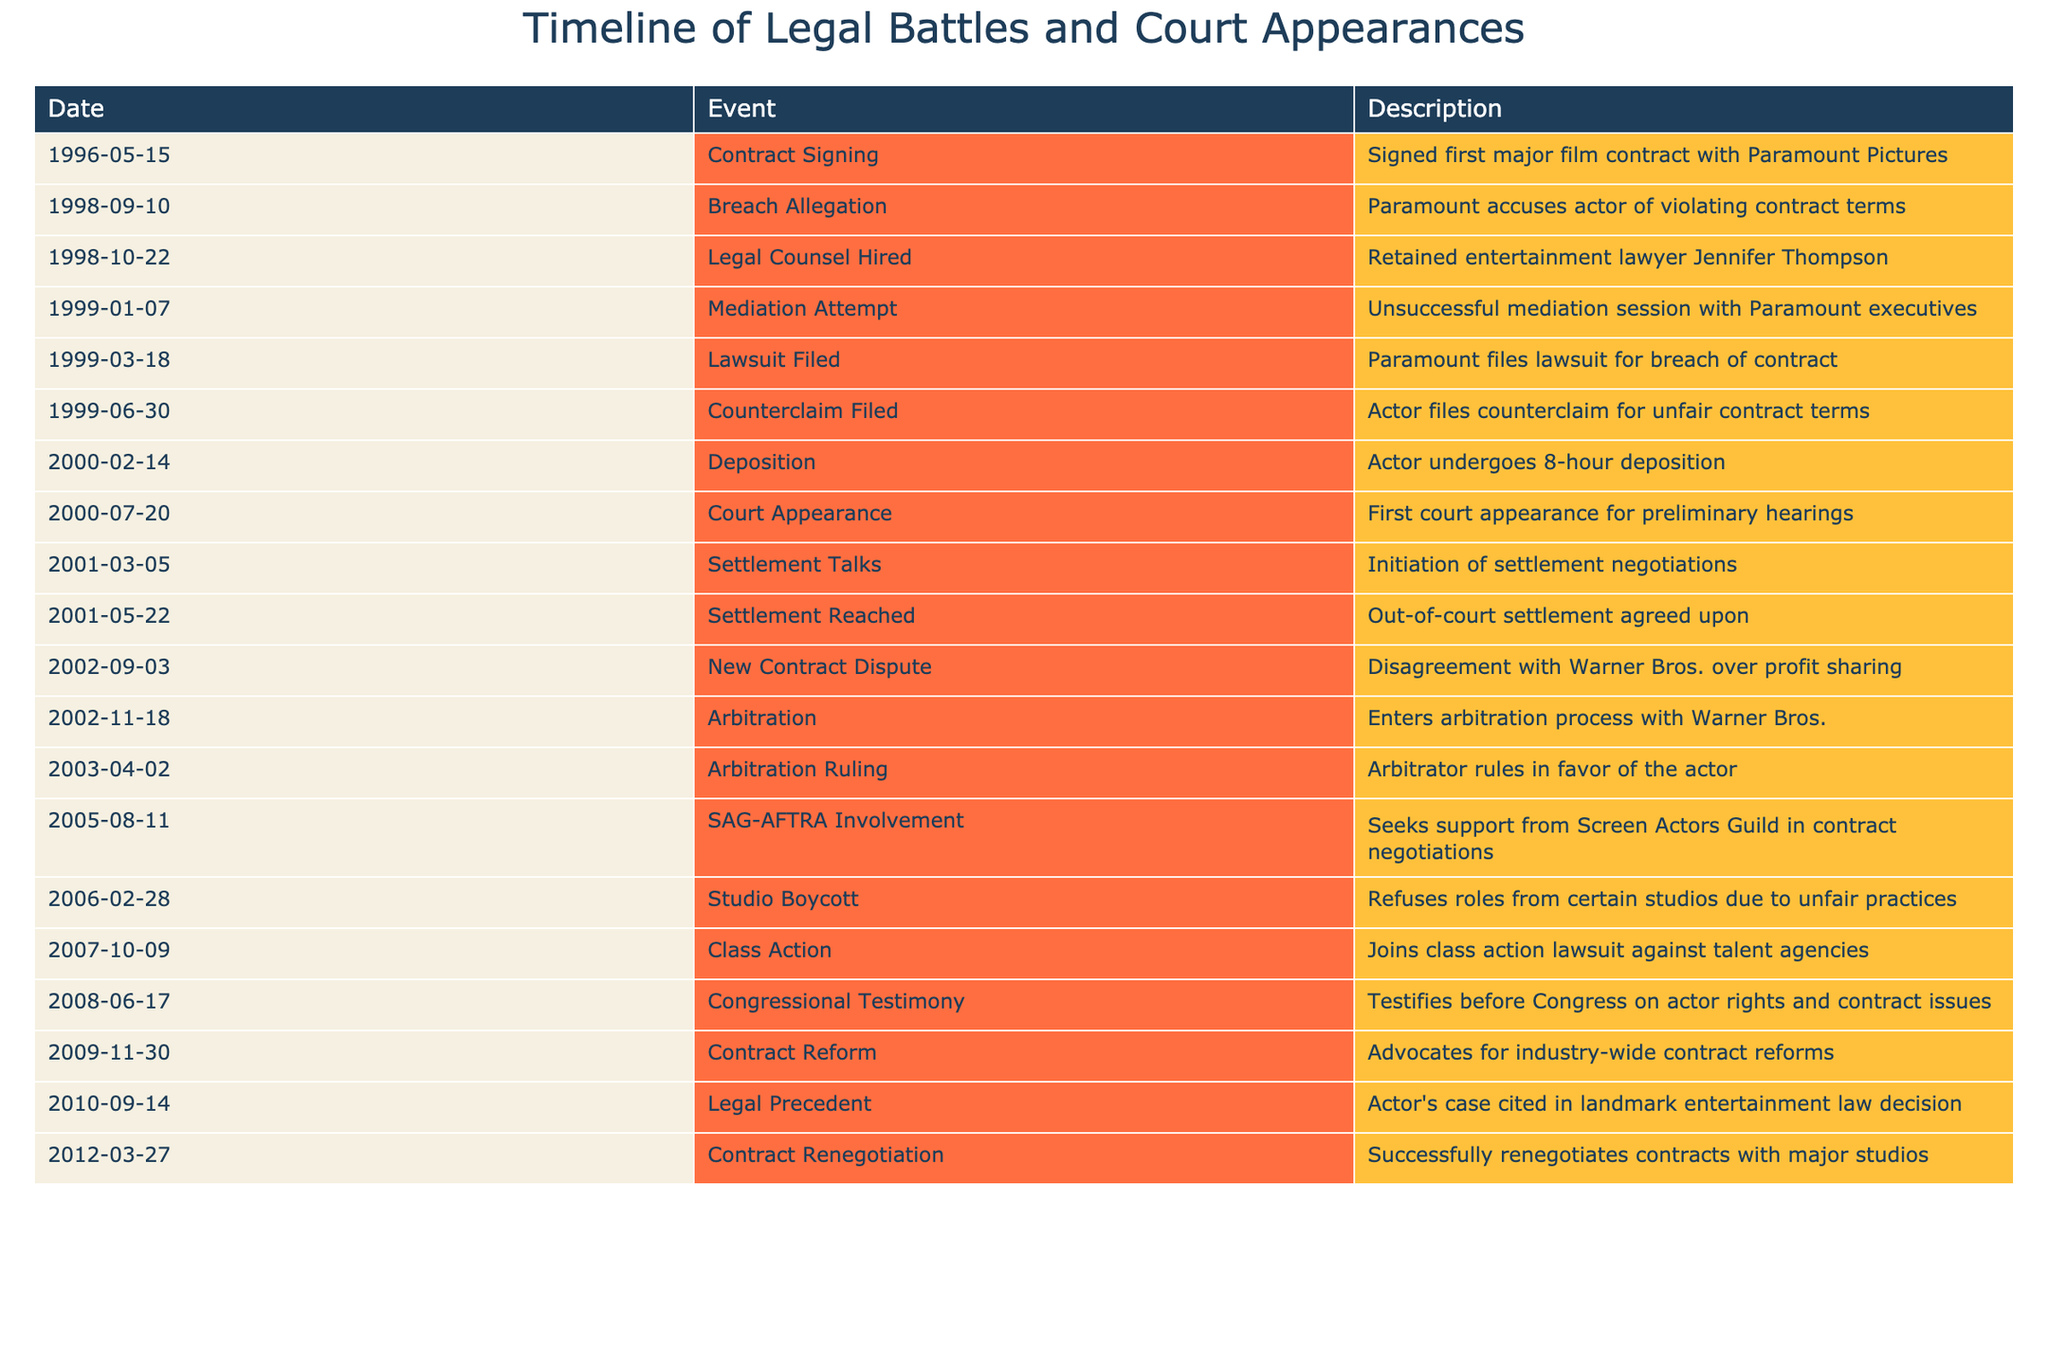What was the date of the first major film contract signing? The first major film contract with Paramount Pictures was signed on May 15, 1996. This is stated directly in the table under the 'Date' column for the event 'Contract Signing.'
Answer: May 15, 1996 How many legal events occurred before the out-of-court settlement was reached? The events that occurred before the settlement reached on May 22, 2001 include: Contract Signing, Breach Allegation, Legal Counsel Hired, Mediation Attempt, Lawsuit Filed, Counterclaim Filed, Deposition, Court Appearance, and Settlement Talks. Counting these events gives a total of 9 legal events.
Answer: 9 Did the actor ever testify before Congress regarding contract issues? Yes, the actor did testify before Congress on June 17, 2008, as indicated in the table. The event titled 'Congressional Testimony' confirms this information.
Answer: Yes In which year did the arbitration ruling occur, and what was the outcome? The arbitration ruling occurred on April 2, 2003, and the outcome was in favor of the actor, as stated in the event 'Arbitration Ruling.' This information is directly reflected in the table.
Answer: 2003, in favor of the actor How many years passed between the first court appearance and the arbitration ruling? The first court appearance occurred on July 20, 2000, and the arbitration ruling was on April 2, 2003. To find the difference, we calculate the time between these dates: from July 2000 to July 2001 is 1 year, and from July 2001 to April 2003 is almost 2 years, giving a total of about 2 years and 9 months between these events.
Answer: About 3 years 